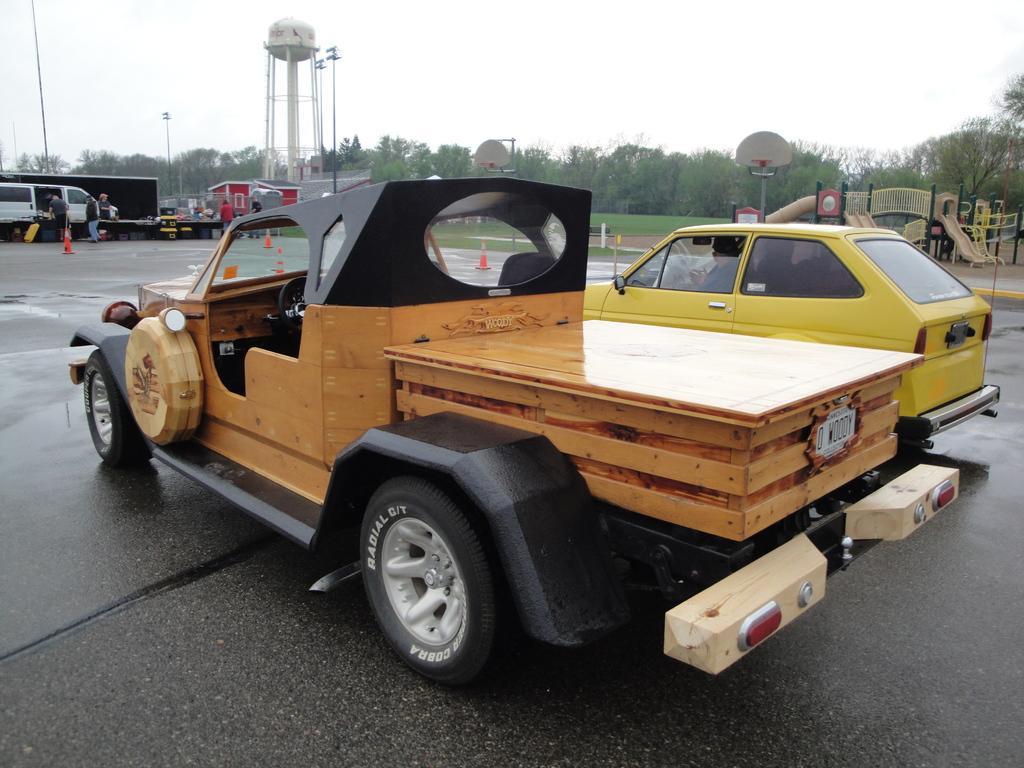In one or two sentences, can you explain what this image depicts? In this picture there is a truck which is parked near to the car. In that car I can see the man who is sitting on the seat. On the left I can see some persons were standing near to the white color van. In the background I can see the shed, trees, stands, grass, plants, poles, street lights and other objects. At the top there is a sky. 